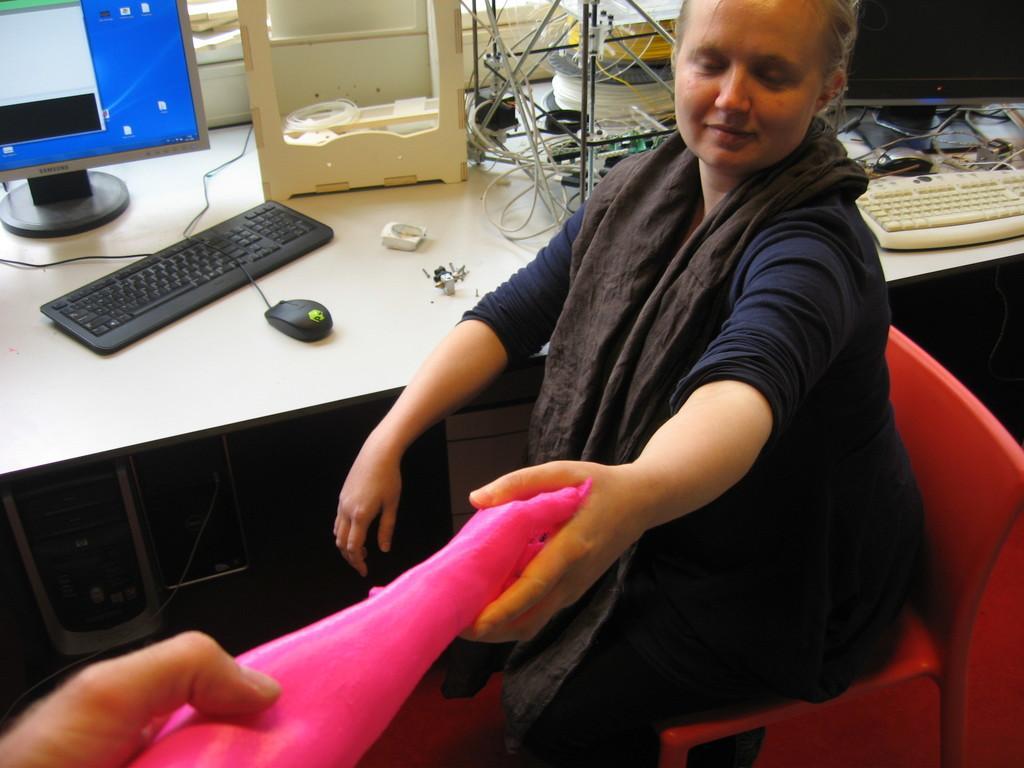How would you summarize this image in a sentence or two? In this image, we can see a person holding an object is sitting. We can see a table with some objects like screens, keyboards, a mouse and some wires. We can also see a white colored object. We can also see some objects at the bottom. 